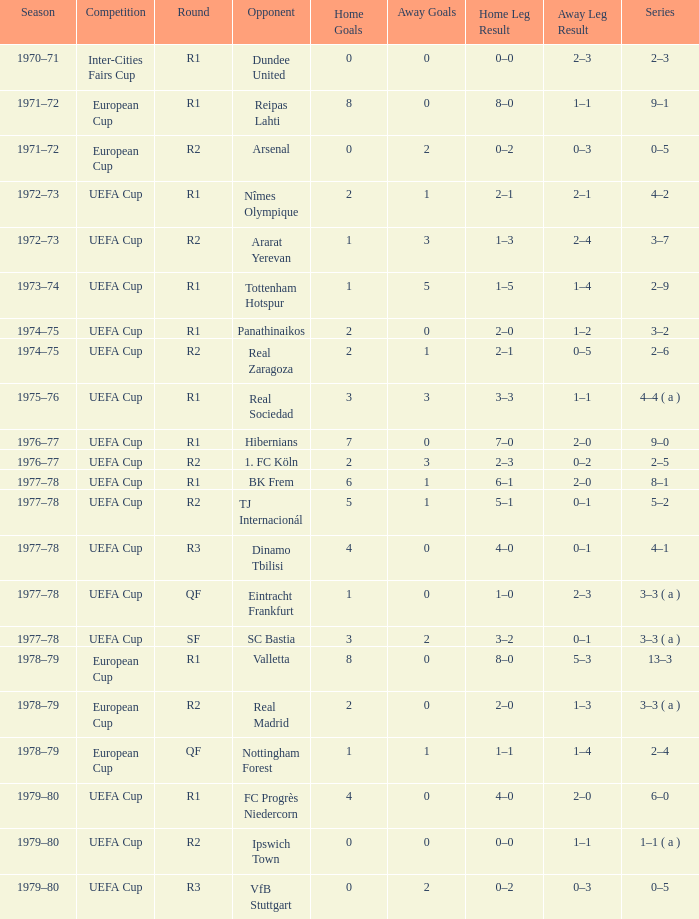Which Series has a Home of 2–0, and an Opponent of panathinaikos? 3–2. 